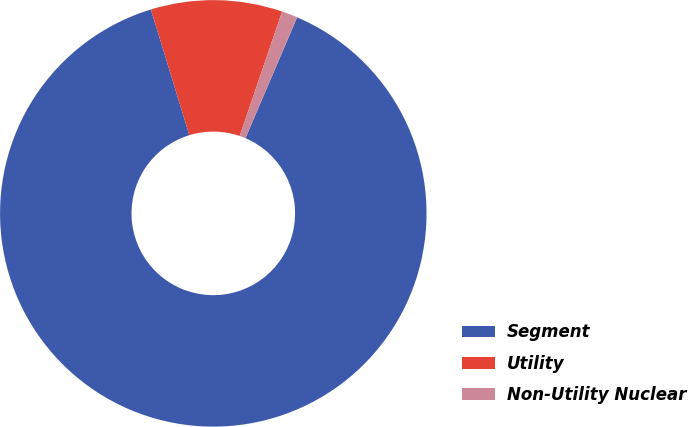<chart> <loc_0><loc_0><loc_500><loc_500><pie_chart><fcel>Segment<fcel>Utility<fcel>Non-Utility Nuclear<nl><fcel>88.84%<fcel>9.96%<fcel>1.2%<nl></chart> 